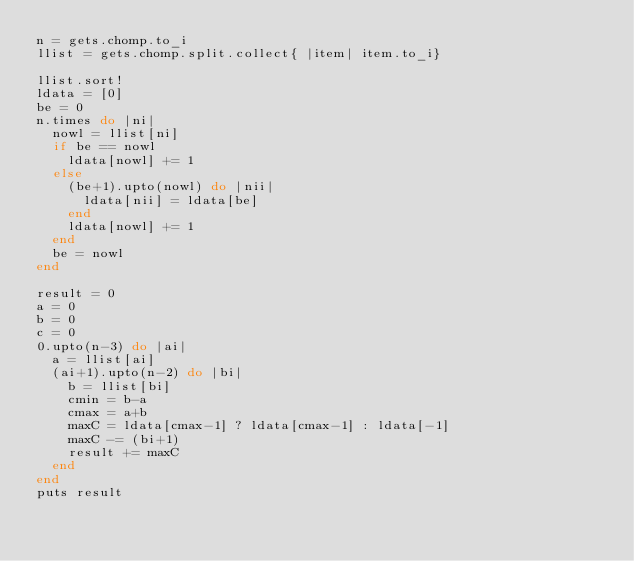<code> <loc_0><loc_0><loc_500><loc_500><_Ruby_>n = gets.chomp.to_i
llist = gets.chomp.split.collect{ |item| item.to_i}

llist.sort!
ldata = [0]
be = 0
n.times do |ni|
  nowl = llist[ni]
  if be == nowl
    ldata[nowl] += 1
  else
    (be+1).upto(nowl) do |nii|
      ldata[nii] = ldata[be]
    end
    ldata[nowl] += 1
  end
  be = nowl
end

result = 0
a = 0
b = 0
c = 0
0.upto(n-3) do |ai|
  a = llist[ai]
  (ai+1).upto(n-2) do |bi|
    b = llist[bi]
    cmin = b-a
    cmax = a+b
    maxC = ldata[cmax-1] ? ldata[cmax-1] : ldata[-1]
    maxC -= (bi+1)
    result += maxC 
  end
end
puts result
</code> 